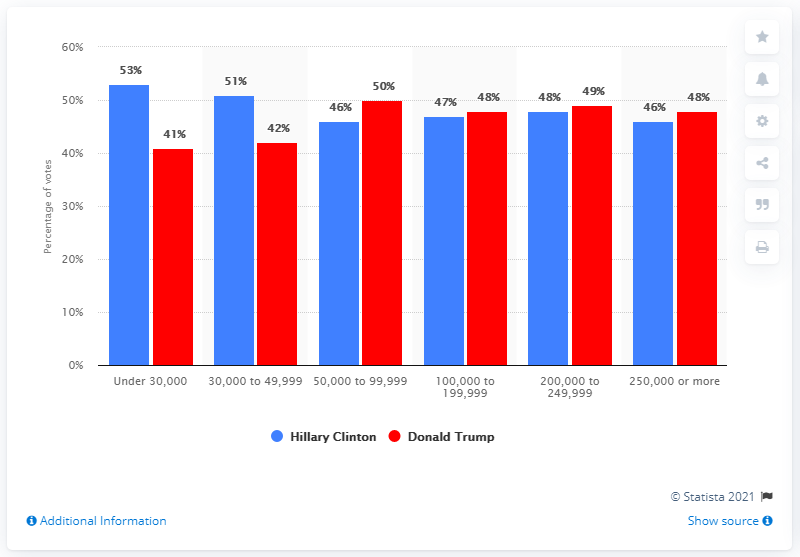Indicate a few pertinent items in this graphic. The biggest difference in income between the candidates was among those under 30,000. The lowest attribute of the red bar was 41. 